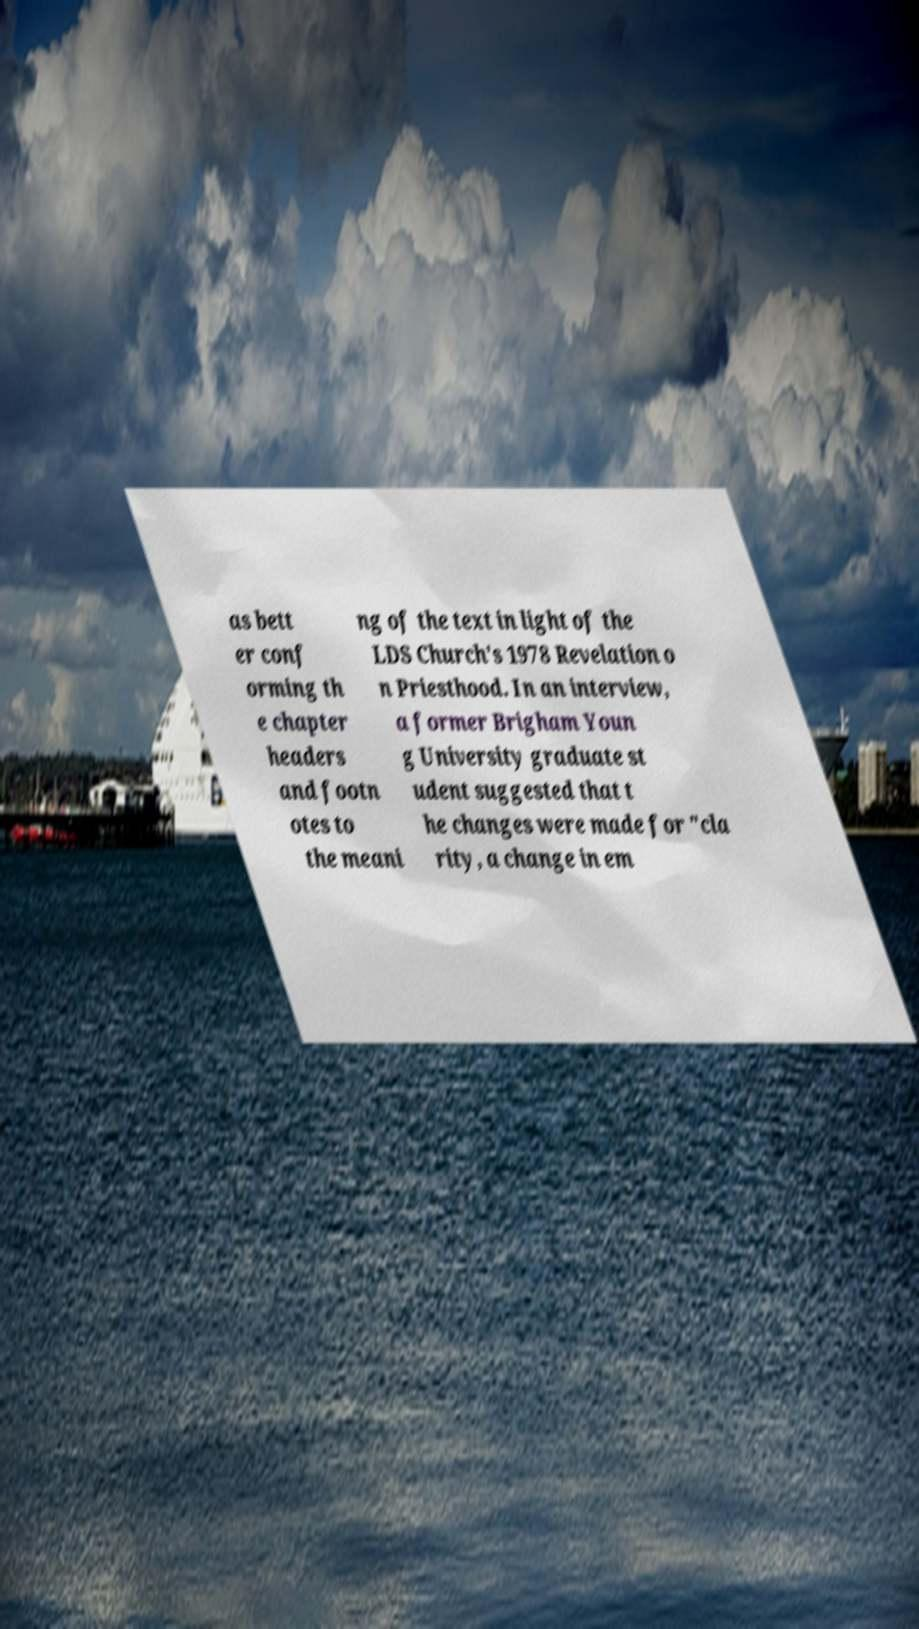For documentation purposes, I need the text within this image transcribed. Could you provide that? as bett er conf orming th e chapter headers and footn otes to the meani ng of the text in light of the LDS Church's 1978 Revelation o n Priesthood. In an interview, a former Brigham Youn g University graduate st udent suggested that t he changes were made for "cla rity, a change in em 